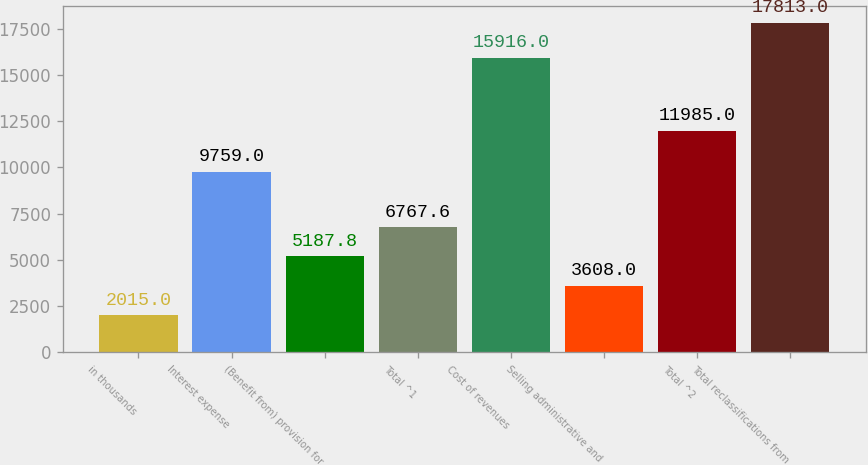Convert chart. <chart><loc_0><loc_0><loc_500><loc_500><bar_chart><fcel>in thousands<fcel>Interest expense<fcel>(Benefit from) provision for<fcel>Total ^1<fcel>Cost of revenues<fcel>Selling administrative and<fcel>Total ^2<fcel>Total reclassifications from<nl><fcel>2015<fcel>9759<fcel>5187.8<fcel>6767.6<fcel>15916<fcel>3608<fcel>11985<fcel>17813<nl></chart> 